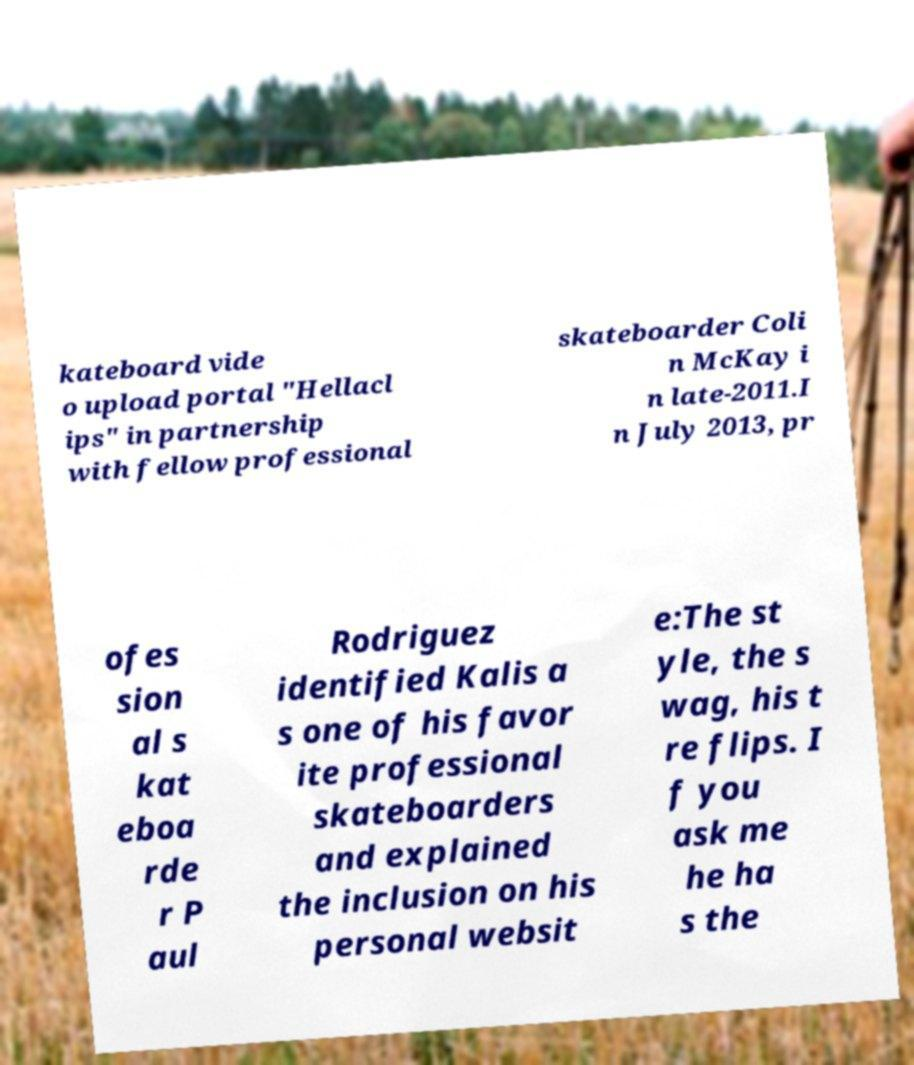For documentation purposes, I need the text within this image transcribed. Could you provide that? kateboard vide o upload portal "Hellacl ips" in partnership with fellow professional skateboarder Coli n McKay i n late-2011.I n July 2013, pr ofes sion al s kat eboa rde r P aul Rodriguez identified Kalis a s one of his favor ite professional skateboarders and explained the inclusion on his personal websit e:The st yle, the s wag, his t re flips. I f you ask me he ha s the 